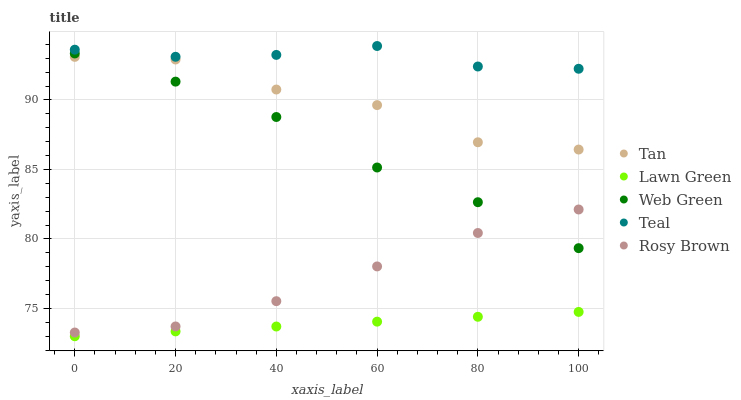Does Lawn Green have the minimum area under the curve?
Answer yes or no. Yes. Does Teal have the maximum area under the curve?
Answer yes or no. Yes. Does Tan have the minimum area under the curve?
Answer yes or no. No. Does Tan have the maximum area under the curve?
Answer yes or no. No. Is Lawn Green the smoothest?
Answer yes or no. Yes. Is Tan the roughest?
Answer yes or no. Yes. Is Rosy Brown the smoothest?
Answer yes or no. No. Is Rosy Brown the roughest?
Answer yes or no. No. Does Lawn Green have the lowest value?
Answer yes or no. Yes. Does Tan have the lowest value?
Answer yes or no. No. Does Teal have the highest value?
Answer yes or no. Yes. Does Tan have the highest value?
Answer yes or no. No. Is Lawn Green less than Teal?
Answer yes or no. Yes. Is Teal greater than Lawn Green?
Answer yes or no. Yes. Does Tan intersect Web Green?
Answer yes or no. Yes. Is Tan less than Web Green?
Answer yes or no. No. Is Tan greater than Web Green?
Answer yes or no. No. Does Lawn Green intersect Teal?
Answer yes or no. No. 